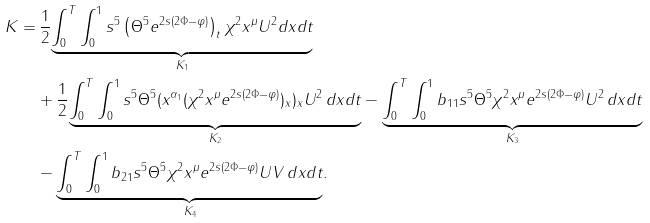<formula> <loc_0><loc_0><loc_500><loc_500>K = & \, \frac { 1 } { 2 } \underset { K _ { 1 } } { \underbrace { \int _ { 0 } ^ { T } \int _ { 0 } ^ { 1 } s ^ { 5 } \left ( \Theta ^ { 5 } e ^ { 2 s ( 2 \Phi - \varphi ) } \right ) _ { t } \chi ^ { 2 } x ^ { \mu } U ^ { 2 } d x d t } } \\ & + \frac { 1 } { 2 } \underset { K _ { 2 } } { \underbrace { \int _ { 0 } ^ { T } \int _ { 0 } ^ { 1 } s ^ { 5 } \Theta ^ { 5 } ( x ^ { \alpha _ { 1 } } ( \chi ^ { 2 } x ^ { \mu } e ^ { 2 s ( 2 \Phi - \varphi ) } ) _ { x } ) _ { x } U ^ { 2 } \, d x d t } } - \underset { K _ { 3 } } { \underbrace { \int _ { 0 } ^ { T } \int _ { 0 } ^ { 1 } b _ { 1 1 } s ^ { 5 } \Theta ^ { 5 } \chi ^ { 2 } x ^ { \mu } e ^ { 2 s ( 2 \Phi - \varphi ) } U ^ { 2 } \, d x d t } } \\ & - \underset { K _ { 4 } } { \underbrace { \int _ { 0 } ^ { T } \int _ { 0 } ^ { 1 } b _ { 2 1 } s ^ { 5 } \Theta ^ { 5 } \chi ^ { 2 } x ^ { \mu } e ^ { 2 s ( 2 \Phi - \varphi ) } U V \, d x d t } } .</formula> 